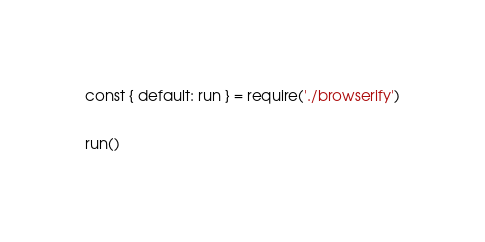<code> <loc_0><loc_0><loc_500><loc_500><_JavaScript_>const { default: run } = require('./browserify')

run()
</code> 